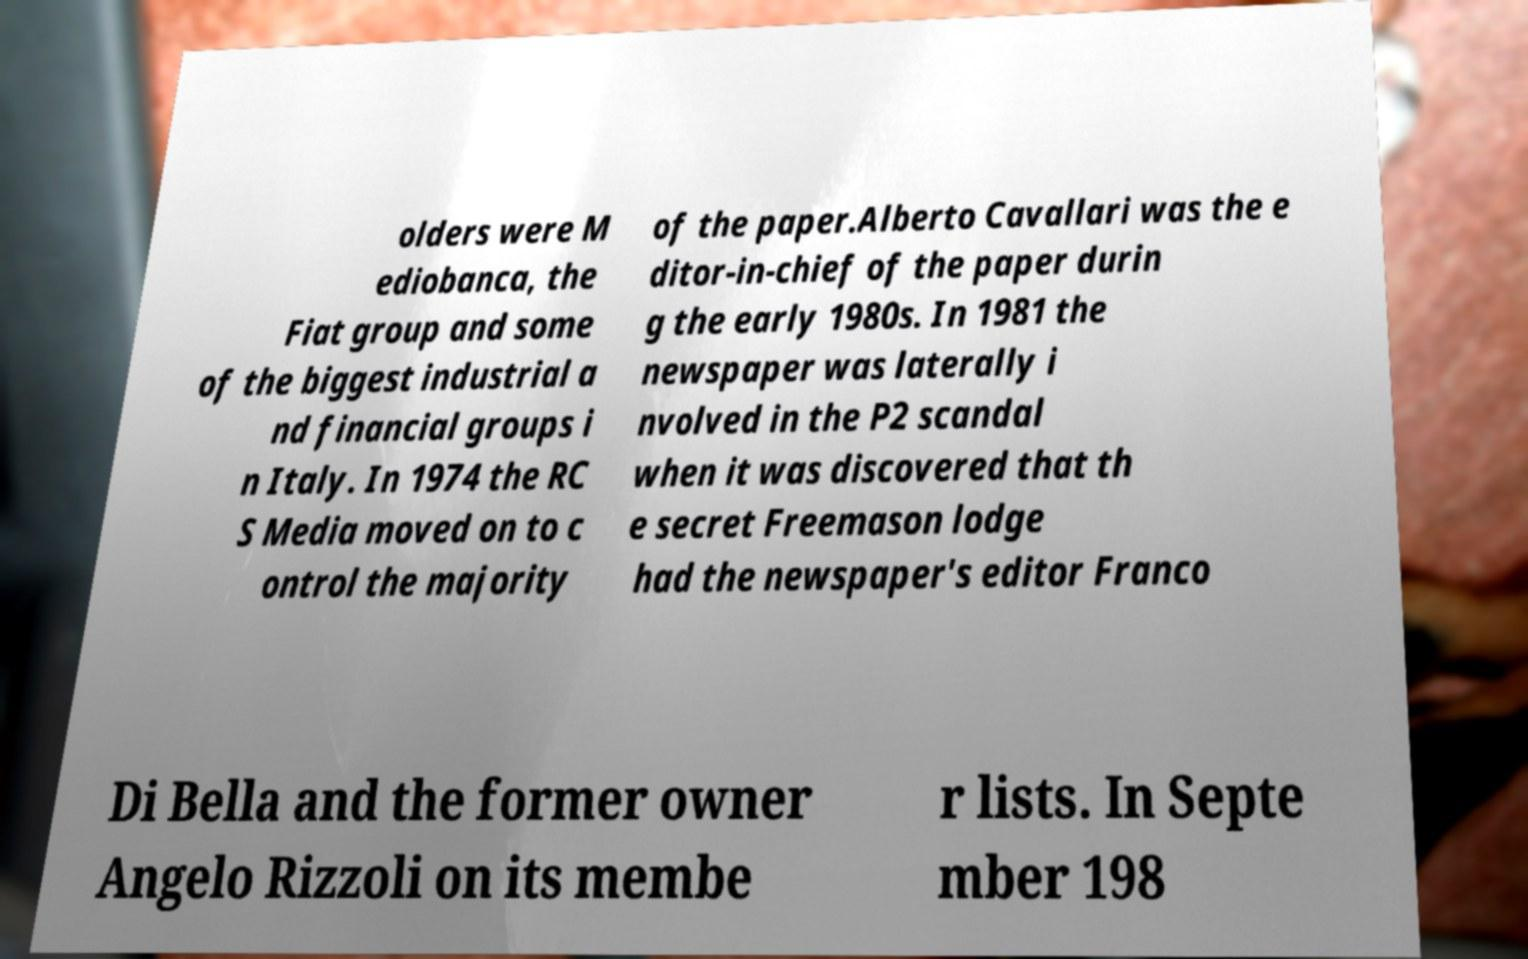Could you extract and type out the text from this image? olders were M ediobanca, the Fiat group and some of the biggest industrial a nd financial groups i n Italy. In 1974 the RC S Media moved on to c ontrol the majority of the paper.Alberto Cavallari was the e ditor-in-chief of the paper durin g the early 1980s. In 1981 the newspaper was laterally i nvolved in the P2 scandal when it was discovered that th e secret Freemason lodge had the newspaper's editor Franco Di Bella and the former owner Angelo Rizzoli on its membe r lists. In Septe mber 198 